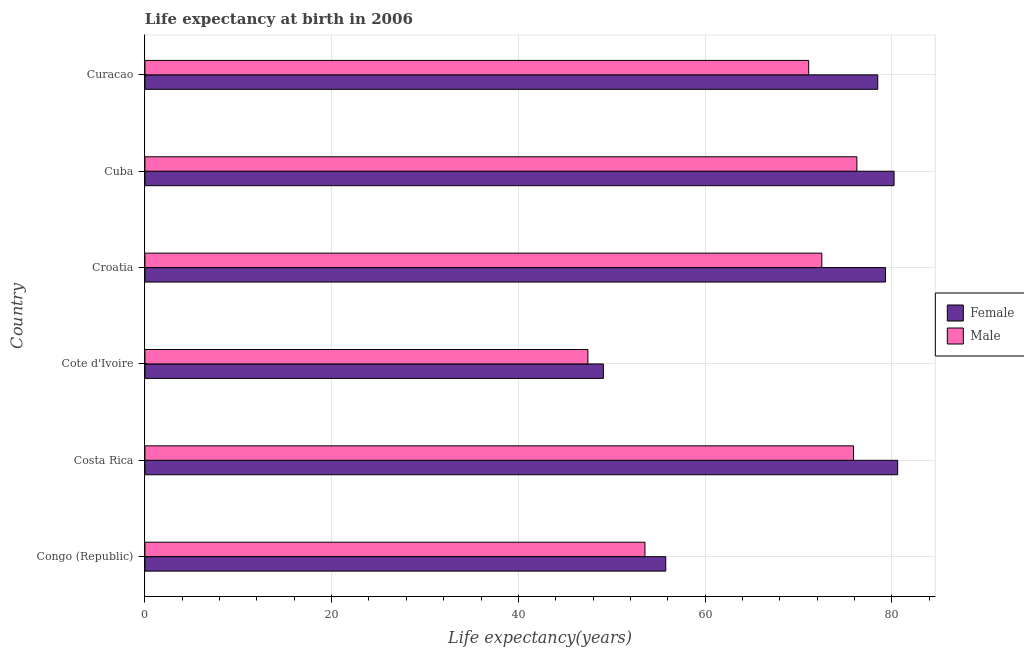How many different coloured bars are there?
Offer a very short reply. 2. What is the label of the 6th group of bars from the top?
Provide a short and direct response. Congo (Republic). In how many cases, is the number of bars for a given country not equal to the number of legend labels?
Provide a succinct answer. 0. What is the life expectancy(male) in Croatia?
Your answer should be compact. 72.51. Across all countries, what is the maximum life expectancy(female)?
Provide a short and direct response. 80.63. Across all countries, what is the minimum life expectancy(male)?
Offer a very short reply. 47.45. In which country was the life expectancy(female) maximum?
Provide a succinct answer. Costa Rica. In which country was the life expectancy(male) minimum?
Make the answer very short. Cote d'Ivoire. What is the total life expectancy(male) in the graph?
Ensure brevity in your answer.  396.78. What is the difference between the life expectancy(male) in Cuba and that in Curacao?
Provide a short and direct response. 5.16. What is the difference between the life expectancy(male) in Cuba and the life expectancy(female) in Congo (Republic)?
Give a very brief answer. 20.47. What is the average life expectancy(female) per country?
Provide a succinct answer. 70.6. What is the difference between the life expectancy(male) and life expectancy(female) in Costa Rica?
Your answer should be very brief. -4.73. What is the ratio of the life expectancy(female) in Cote d'Ivoire to that in Croatia?
Your answer should be compact. 0.62. What is the difference between the highest and the second highest life expectancy(female)?
Give a very brief answer. 0.39. What is the difference between the highest and the lowest life expectancy(female)?
Offer a very short reply. 31.52. In how many countries, is the life expectancy(female) greater than the average life expectancy(female) taken over all countries?
Ensure brevity in your answer.  4. What does the 2nd bar from the bottom in Congo (Republic) represents?
Provide a succinct answer. Male. How many bars are there?
Offer a terse response. 12. Are the values on the major ticks of X-axis written in scientific E-notation?
Ensure brevity in your answer.  No. Where does the legend appear in the graph?
Give a very brief answer. Center right. How many legend labels are there?
Your answer should be very brief. 2. What is the title of the graph?
Offer a terse response. Life expectancy at birth in 2006. What is the label or title of the X-axis?
Make the answer very short. Life expectancy(years). What is the Life expectancy(years) in Female in Congo (Republic)?
Your response must be concise. 55.79. What is the Life expectancy(years) in Male in Congo (Republic)?
Offer a terse response. 53.56. What is the Life expectancy(years) in Female in Costa Rica?
Your answer should be very brief. 80.63. What is the Life expectancy(years) of Male in Costa Rica?
Your response must be concise. 75.9. What is the Life expectancy(years) of Female in Cote d'Ivoire?
Keep it short and to the point. 49.11. What is the Life expectancy(years) in Male in Cote d'Ivoire?
Give a very brief answer. 47.45. What is the Life expectancy(years) of Female in Croatia?
Give a very brief answer. 79.33. What is the Life expectancy(years) of Male in Croatia?
Your response must be concise. 72.51. What is the Life expectancy(years) in Female in Cuba?
Your response must be concise. 80.25. What is the Life expectancy(years) of Male in Cuba?
Your answer should be very brief. 76.26. What is the Life expectancy(years) in Female in Curacao?
Your answer should be compact. 78.5. What is the Life expectancy(years) of Male in Curacao?
Make the answer very short. 71.1. Across all countries, what is the maximum Life expectancy(years) in Female?
Offer a terse response. 80.63. Across all countries, what is the maximum Life expectancy(years) in Male?
Ensure brevity in your answer.  76.26. Across all countries, what is the minimum Life expectancy(years) of Female?
Your answer should be compact. 49.11. Across all countries, what is the minimum Life expectancy(years) in Male?
Give a very brief answer. 47.45. What is the total Life expectancy(years) in Female in the graph?
Your answer should be compact. 423.6. What is the total Life expectancy(years) of Male in the graph?
Your answer should be compact. 396.78. What is the difference between the Life expectancy(years) of Female in Congo (Republic) and that in Costa Rica?
Give a very brief answer. -24.84. What is the difference between the Life expectancy(years) of Male in Congo (Republic) and that in Costa Rica?
Offer a terse response. -22.34. What is the difference between the Life expectancy(years) of Female in Congo (Republic) and that in Cote d'Ivoire?
Your response must be concise. 6.68. What is the difference between the Life expectancy(years) in Male in Congo (Republic) and that in Cote d'Ivoire?
Offer a terse response. 6.11. What is the difference between the Life expectancy(years) in Female in Congo (Republic) and that in Croatia?
Your answer should be very brief. -23.54. What is the difference between the Life expectancy(years) in Male in Congo (Republic) and that in Croatia?
Provide a succinct answer. -18.95. What is the difference between the Life expectancy(years) in Female in Congo (Republic) and that in Cuba?
Keep it short and to the point. -24.46. What is the difference between the Life expectancy(years) of Male in Congo (Republic) and that in Cuba?
Provide a succinct answer. -22.7. What is the difference between the Life expectancy(years) of Female in Congo (Republic) and that in Curacao?
Ensure brevity in your answer.  -22.71. What is the difference between the Life expectancy(years) in Male in Congo (Republic) and that in Curacao?
Provide a short and direct response. -17.54. What is the difference between the Life expectancy(years) in Female in Costa Rica and that in Cote d'Ivoire?
Your answer should be compact. 31.52. What is the difference between the Life expectancy(years) of Male in Costa Rica and that in Cote d'Ivoire?
Your response must be concise. 28.45. What is the difference between the Life expectancy(years) of Female in Costa Rica and that in Croatia?
Provide a succinct answer. 1.3. What is the difference between the Life expectancy(years) of Male in Costa Rica and that in Croatia?
Offer a terse response. 3.39. What is the difference between the Life expectancy(years) of Female in Costa Rica and that in Cuba?
Your response must be concise. 0.39. What is the difference between the Life expectancy(years) of Male in Costa Rica and that in Cuba?
Make the answer very short. -0.36. What is the difference between the Life expectancy(years) of Female in Costa Rica and that in Curacao?
Offer a very short reply. 2.13. What is the difference between the Life expectancy(years) of Female in Cote d'Ivoire and that in Croatia?
Your answer should be compact. -30.22. What is the difference between the Life expectancy(years) in Male in Cote d'Ivoire and that in Croatia?
Provide a succinct answer. -25.06. What is the difference between the Life expectancy(years) in Female in Cote d'Ivoire and that in Cuba?
Your answer should be compact. -31.14. What is the difference between the Life expectancy(years) of Male in Cote d'Ivoire and that in Cuba?
Your answer should be very brief. -28.82. What is the difference between the Life expectancy(years) in Female in Cote d'Ivoire and that in Curacao?
Your response must be concise. -29.39. What is the difference between the Life expectancy(years) in Male in Cote d'Ivoire and that in Curacao?
Give a very brief answer. -23.65. What is the difference between the Life expectancy(years) of Female in Croatia and that in Cuba?
Provide a succinct answer. -0.92. What is the difference between the Life expectancy(years) in Male in Croatia and that in Cuba?
Offer a terse response. -3.75. What is the difference between the Life expectancy(years) of Female in Croatia and that in Curacao?
Your answer should be very brief. 0.83. What is the difference between the Life expectancy(years) in Male in Croatia and that in Curacao?
Your response must be concise. 1.41. What is the difference between the Life expectancy(years) in Female in Cuba and that in Curacao?
Provide a succinct answer. 1.75. What is the difference between the Life expectancy(years) of Male in Cuba and that in Curacao?
Make the answer very short. 5.16. What is the difference between the Life expectancy(years) in Female in Congo (Republic) and the Life expectancy(years) in Male in Costa Rica?
Provide a succinct answer. -20.11. What is the difference between the Life expectancy(years) of Female in Congo (Republic) and the Life expectancy(years) of Male in Cote d'Ivoire?
Offer a very short reply. 8.34. What is the difference between the Life expectancy(years) in Female in Congo (Republic) and the Life expectancy(years) in Male in Croatia?
Your answer should be very brief. -16.72. What is the difference between the Life expectancy(years) of Female in Congo (Republic) and the Life expectancy(years) of Male in Cuba?
Provide a short and direct response. -20.48. What is the difference between the Life expectancy(years) in Female in Congo (Republic) and the Life expectancy(years) in Male in Curacao?
Your response must be concise. -15.31. What is the difference between the Life expectancy(years) of Female in Costa Rica and the Life expectancy(years) of Male in Cote d'Ivoire?
Offer a very short reply. 33.18. What is the difference between the Life expectancy(years) in Female in Costa Rica and the Life expectancy(years) in Male in Croatia?
Provide a succinct answer. 8.12. What is the difference between the Life expectancy(years) of Female in Costa Rica and the Life expectancy(years) of Male in Cuba?
Give a very brief answer. 4.37. What is the difference between the Life expectancy(years) in Female in Costa Rica and the Life expectancy(years) in Male in Curacao?
Your response must be concise. 9.53. What is the difference between the Life expectancy(years) of Female in Cote d'Ivoire and the Life expectancy(years) of Male in Croatia?
Offer a terse response. -23.4. What is the difference between the Life expectancy(years) of Female in Cote d'Ivoire and the Life expectancy(years) of Male in Cuba?
Your response must be concise. -27.16. What is the difference between the Life expectancy(years) in Female in Cote d'Ivoire and the Life expectancy(years) in Male in Curacao?
Make the answer very short. -21.99. What is the difference between the Life expectancy(years) in Female in Croatia and the Life expectancy(years) in Male in Cuba?
Provide a short and direct response. 3.07. What is the difference between the Life expectancy(years) in Female in Croatia and the Life expectancy(years) in Male in Curacao?
Offer a very short reply. 8.23. What is the difference between the Life expectancy(years) of Female in Cuba and the Life expectancy(years) of Male in Curacao?
Offer a terse response. 9.14. What is the average Life expectancy(years) in Female per country?
Provide a succinct answer. 70.6. What is the average Life expectancy(years) in Male per country?
Your response must be concise. 66.13. What is the difference between the Life expectancy(years) of Female and Life expectancy(years) of Male in Congo (Republic)?
Your answer should be very brief. 2.23. What is the difference between the Life expectancy(years) of Female and Life expectancy(years) of Male in Costa Rica?
Ensure brevity in your answer.  4.73. What is the difference between the Life expectancy(years) in Female and Life expectancy(years) in Male in Cote d'Ivoire?
Offer a very short reply. 1.66. What is the difference between the Life expectancy(years) in Female and Life expectancy(years) in Male in Croatia?
Ensure brevity in your answer.  6.82. What is the difference between the Life expectancy(years) of Female and Life expectancy(years) of Male in Cuba?
Ensure brevity in your answer.  3.98. What is the difference between the Life expectancy(years) in Female and Life expectancy(years) in Male in Curacao?
Provide a short and direct response. 7.4. What is the ratio of the Life expectancy(years) in Female in Congo (Republic) to that in Costa Rica?
Give a very brief answer. 0.69. What is the ratio of the Life expectancy(years) in Male in Congo (Republic) to that in Costa Rica?
Keep it short and to the point. 0.71. What is the ratio of the Life expectancy(years) in Female in Congo (Republic) to that in Cote d'Ivoire?
Keep it short and to the point. 1.14. What is the ratio of the Life expectancy(years) of Male in Congo (Republic) to that in Cote d'Ivoire?
Keep it short and to the point. 1.13. What is the ratio of the Life expectancy(years) of Female in Congo (Republic) to that in Croatia?
Make the answer very short. 0.7. What is the ratio of the Life expectancy(years) in Male in Congo (Republic) to that in Croatia?
Offer a terse response. 0.74. What is the ratio of the Life expectancy(years) of Female in Congo (Republic) to that in Cuba?
Offer a very short reply. 0.7. What is the ratio of the Life expectancy(years) in Male in Congo (Republic) to that in Cuba?
Offer a terse response. 0.7. What is the ratio of the Life expectancy(years) of Female in Congo (Republic) to that in Curacao?
Your answer should be very brief. 0.71. What is the ratio of the Life expectancy(years) in Male in Congo (Republic) to that in Curacao?
Offer a very short reply. 0.75. What is the ratio of the Life expectancy(years) of Female in Costa Rica to that in Cote d'Ivoire?
Keep it short and to the point. 1.64. What is the ratio of the Life expectancy(years) in Male in Costa Rica to that in Cote d'Ivoire?
Keep it short and to the point. 1.6. What is the ratio of the Life expectancy(years) of Female in Costa Rica to that in Croatia?
Ensure brevity in your answer.  1.02. What is the ratio of the Life expectancy(years) in Male in Costa Rica to that in Croatia?
Your answer should be compact. 1.05. What is the ratio of the Life expectancy(years) of Male in Costa Rica to that in Cuba?
Offer a terse response. 1. What is the ratio of the Life expectancy(years) of Female in Costa Rica to that in Curacao?
Give a very brief answer. 1.03. What is the ratio of the Life expectancy(years) in Male in Costa Rica to that in Curacao?
Make the answer very short. 1.07. What is the ratio of the Life expectancy(years) of Female in Cote d'Ivoire to that in Croatia?
Offer a terse response. 0.62. What is the ratio of the Life expectancy(years) in Male in Cote d'Ivoire to that in Croatia?
Provide a succinct answer. 0.65. What is the ratio of the Life expectancy(years) in Female in Cote d'Ivoire to that in Cuba?
Offer a very short reply. 0.61. What is the ratio of the Life expectancy(years) of Male in Cote d'Ivoire to that in Cuba?
Offer a terse response. 0.62. What is the ratio of the Life expectancy(years) in Female in Cote d'Ivoire to that in Curacao?
Your answer should be compact. 0.63. What is the ratio of the Life expectancy(years) in Male in Cote d'Ivoire to that in Curacao?
Your answer should be compact. 0.67. What is the ratio of the Life expectancy(years) of Female in Croatia to that in Cuba?
Your answer should be compact. 0.99. What is the ratio of the Life expectancy(years) of Male in Croatia to that in Cuba?
Offer a terse response. 0.95. What is the ratio of the Life expectancy(years) of Female in Croatia to that in Curacao?
Provide a succinct answer. 1.01. What is the ratio of the Life expectancy(years) in Male in Croatia to that in Curacao?
Your answer should be compact. 1.02. What is the ratio of the Life expectancy(years) of Female in Cuba to that in Curacao?
Your answer should be compact. 1.02. What is the ratio of the Life expectancy(years) of Male in Cuba to that in Curacao?
Make the answer very short. 1.07. What is the difference between the highest and the second highest Life expectancy(years) of Female?
Offer a terse response. 0.39. What is the difference between the highest and the second highest Life expectancy(years) of Male?
Ensure brevity in your answer.  0.36. What is the difference between the highest and the lowest Life expectancy(years) of Female?
Provide a succinct answer. 31.52. What is the difference between the highest and the lowest Life expectancy(years) of Male?
Provide a succinct answer. 28.82. 